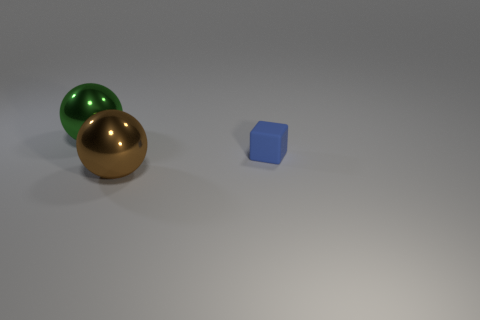How many things are either big spheres behind the blue matte block or blocks on the right side of the green ball?
Make the answer very short. 2. Are there fewer tiny green rubber things than large green spheres?
Your answer should be very brief. Yes. How many things are cyan cubes or shiny spheres?
Your answer should be compact. 2. Does the small rubber object have the same shape as the big brown shiny object?
Make the answer very short. No. Is there anything else that has the same material as the big brown thing?
Ensure brevity in your answer.  Yes. Are there an equal number of tiny blue cubes and big yellow shiny objects?
Provide a succinct answer. No. Is the size of the ball that is in front of the large green sphere the same as the thing behind the tiny rubber object?
Provide a short and direct response. Yes. What is the material of the thing that is right of the big green sphere and behind the brown metallic ball?
Your answer should be compact. Rubber. Is there anything else of the same color as the small thing?
Your response must be concise. No. Is the number of green metallic things to the left of the green ball less than the number of brown shiny things?
Ensure brevity in your answer.  Yes. 